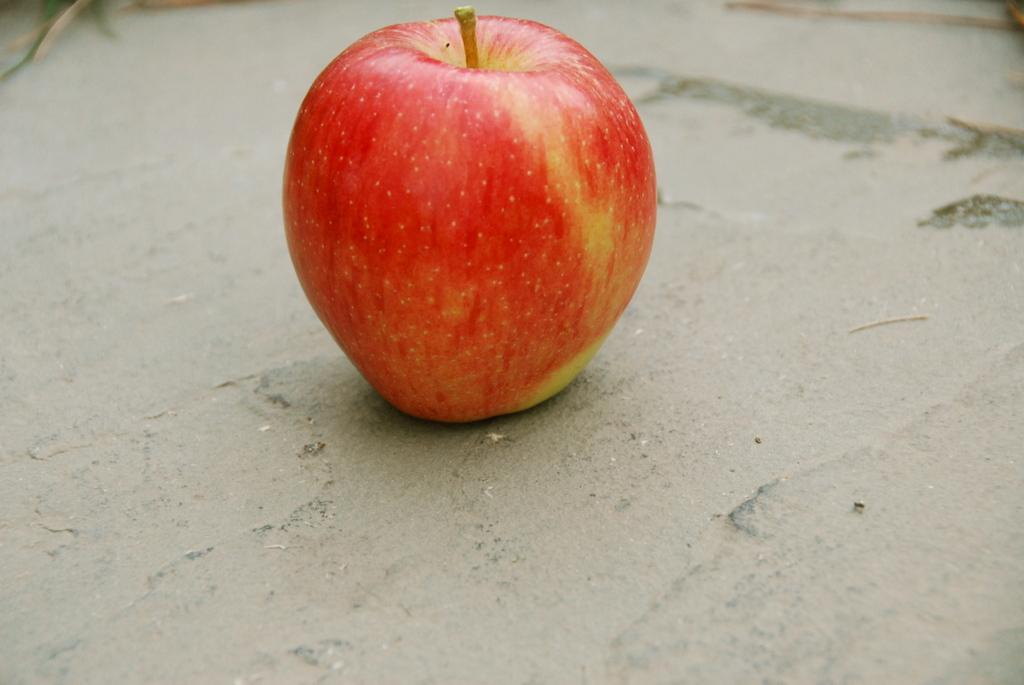What is the main object in the image? There is an apple in the image. Where is the apple located? The apple is placed on a surface. How many trucks are parked downtown near the beast in the image? There are no trucks, downtown, or beasts present in the image; it only features an apple on a surface. 